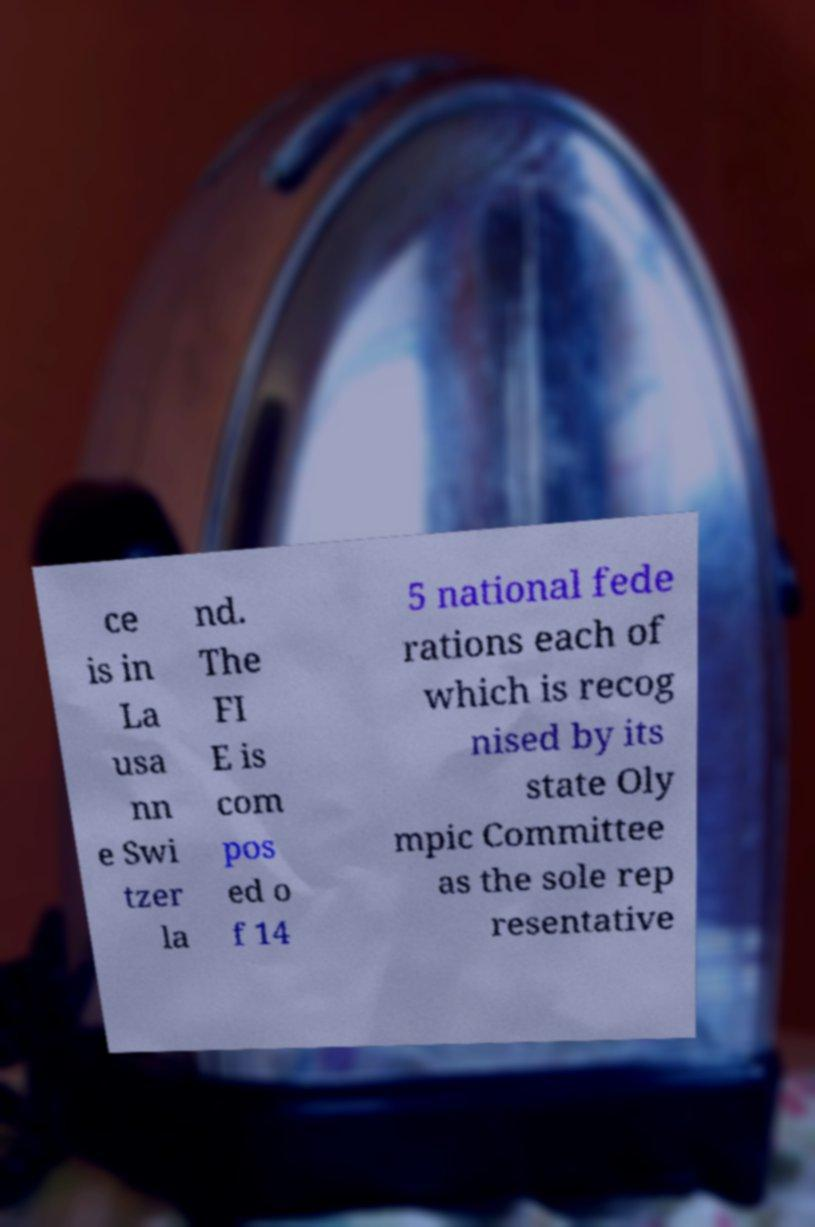Could you assist in decoding the text presented in this image and type it out clearly? ce is in La usa nn e Swi tzer la nd. The FI E is com pos ed o f 14 5 national fede rations each of which is recog nised by its state Oly mpic Committee as the sole rep resentative 